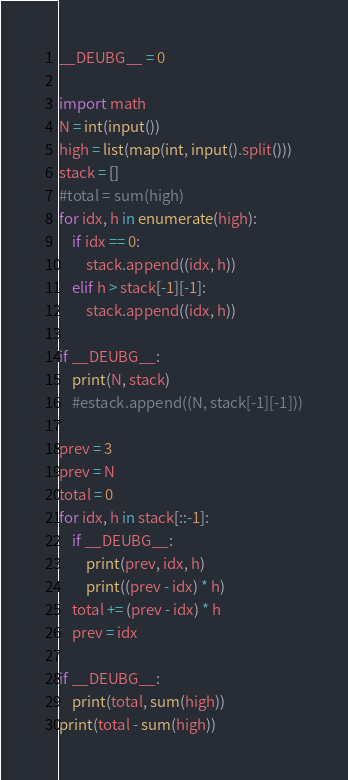Convert code to text. <code><loc_0><loc_0><loc_500><loc_500><_Python_>__DEUBG__ = 0

import math
N = int(input())
high = list(map(int, input().split()))
stack = []
#total = sum(high)
for idx, h in enumerate(high):
    if idx == 0:
        stack.append((idx, h))
    elif h > stack[-1][-1]:
        stack.append((idx, h))

if __DEUBG__:
    print(N, stack)
    #estack.append((N, stack[-1][-1]))

prev = 3
prev = N
total = 0
for idx, h in stack[::-1]:
    if __DEUBG__:
        print(prev, idx, h)
        print((prev - idx) * h)
    total += (prev - idx) * h
    prev = idx

if __DEUBG__:
    print(total, sum(high))
print(total - sum(high))
</code> 